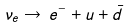<formula> <loc_0><loc_0><loc_500><loc_500>\nu _ { e } \rightarrow \, e ^ { - } + u + \bar { d }</formula> 